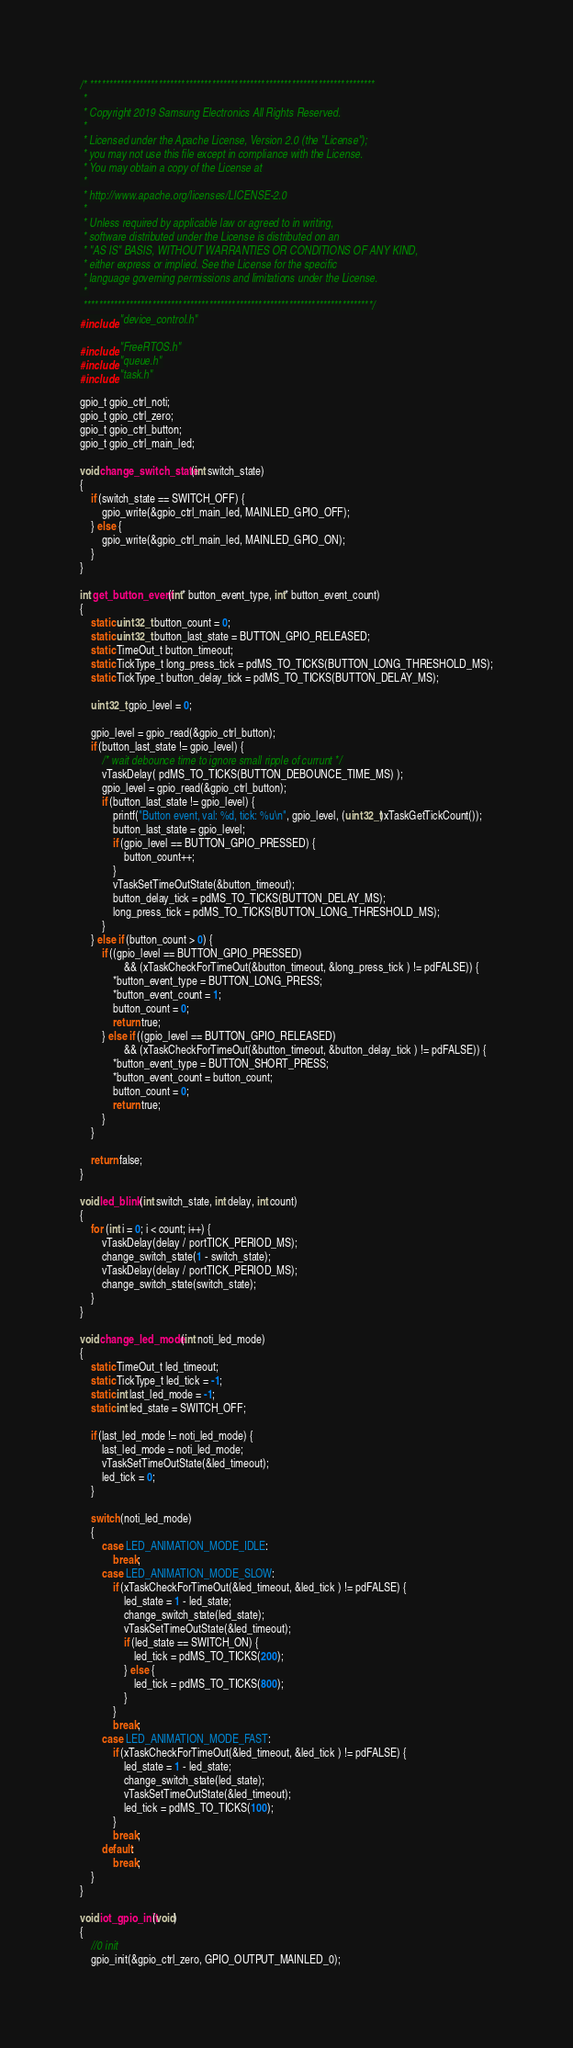<code> <loc_0><loc_0><loc_500><loc_500><_C_>/* ***************************************************************************
 *
 * Copyright 2019 Samsung Electronics All Rights Reserved.
 *
 * Licensed under the Apache License, Version 2.0 (the "License");
 * you may not use this file except in compliance with the License.
 * You may obtain a copy of the License at
 *
 * http://www.apache.org/licenses/LICENSE-2.0
 *
 * Unless required by applicable law or agreed to in writing,
 * software distributed under the License is distributed on an
 * "AS IS" BASIS, WITHOUT WARRANTIES OR CONDITIONS OF ANY KIND,
 * either express or implied. See the License for the specific
 * language governing permissions and limitations under the License.
 *
 ****************************************************************************/
#include "device_control.h"

#include "FreeRTOS.h"
#include "queue.h"
#include "task.h"

gpio_t gpio_ctrl_noti;
gpio_t gpio_ctrl_zero;
gpio_t gpio_ctrl_button;
gpio_t gpio_ctrl_main_led;

void change_switch_state(int switch_state)
{
    if (switch_state == SWITCH_OFF) {
        gpio_write(&gpio_ctrl_main_led, MAINLED_GPIO_OFF);
    } else {
        gpio_write(&gpio_ctrl_main_led, MAINLED_GPIO_ON);
    }
}

int get_button_event(int* button_event_type, int* button_event_count)
{
	static uint32_t button_count = 0;
	static uint32_t button_last_state = BUTTON_GPIO_RELEASED;
	static TimeOut_t button_timeout;
	static TickType_t long_press_tick = pdMS_TO_TICKS(BUTTON_LONG_THRESHOLD_MS);
	static TickType_t button_delay_tick = pdMS_TO_TICKS(BUTTON_DELAY_MS);

	uint32_t gpio_level = 0;

	gpio_level = gpio_read(&gpio_ctrl_button);
	if (button_last_state != gpio_level) {
		/* wait debounce time to ignore small ripple of currunt */
		vTaskDelay( pdMS_TO_TICKS(BUTTON_DEBOUNCE_TIME_MS) );
		gpio_level = gpio_read(&gpio_ctrl_button);
		if (button_last_state != gpio_level) {
			printf("Button event, val: %d, tick: %u\n", gpio_level, (uint32_t)xTaskGetTickCount());
			button_last_state = gpio_level;
			if (gpio_level == BUTTON_GPIO_PRESSED) {
				button_count++;
			}
			vTaskSetTimeOutState(&button_timeout);
			button_delay_tick = pdMS_TO_TICKS(BUTTON_DELAY_MS);
			long_press_tick = pdMS_TO_TICKS(BUTTON_LONG_THRESHOLD_MS);
		}
	} else if (button_count > 0) {
		if ((gpio_level == BUTTON_GPIO_PRESSED)
				&& (xTaskCheckForTimeOut(&button_timeout, &long_press_tick ) != pdFALSE)) {
			*button_event_type = BUTTON_LONG_PRESS;
			*button_event_count = 1;
			button_count = 0;
			return true;
		} else if ((gpio_level == BUTTON_GPIO_RELEASED)
				&& (xTaskCheckForTimeOut(&button_timeout, &button_delay_tick ) != pdFALSE)) {
			*button_event_type = BUTTON_SHORT_PRESS;
			*button_event_count = button_count;
			button_count = 0;
			return true;
		}
	}

	return false;
}

void led_blink(int switch_state, int delay, int count)
{
	for (int i = 0; i < count; i++) {
		vTaskDelay(delay / portTICK_PERIOD_MS);
        change_switch_state(1 - switch_state);
		vTaskDelay(delay / portTICK_PERIOD_MS);
        change_switch_state(switch_state);
	}
}

void change_led_mode(int noti_led_mode)
{
    static TimeOut_t led_timeout;
    static TickType_t led_tick = -1;
    static int last_led_mode = -1;
    static int led_state = SWITCH_OFF;

    if (last_led_mode != noti_led_mode) {
        last_led_mode = noti_led_mode;
        vTaskSetTimeOutState(&led_timeout);
        led_tick = 0;
    }

    switch (noti_led_mode)
    {
        case LED_ANIMATION_MODE_IDLE:
            break;
        case LED_ANIMATION_MODE_SLOW:
            if (xTaskCheckForTimeOut(&led_timeout, &led_tick ) != pdFALSE) {
                led_state = 1 - led_state;
                change_switch_state(led_state);
                vTaskSetTimeOutState(&led_timeout);
                if (led_state == SWITCH_ON) {
                    led_tick = pdMS_TO_TICKS(200);
                } else {
                    led_tick = pdMS_TO_TICKS(800);
                }
            }
            break;
        case LED_ANIMATION_MODE_FAST:
            if (xTaskCheckForTimeOut(&led_timeout, &led_tick ) != pdFALSE) {
                led_state = 1 - led_state;
                change_switch_state(led_state);
                vTaskSetTimeOutState(&led_timeout);
                led_tick = pdMS_TO_TICKS(100);
            }
            break;
        default:
            break;
    }
}

void iot_gpio_init(void)
{
	//0 init
	gpio_init(&gpio_ctrl_zero, GPIO_OUTPUT_MAINLED_0);</code> 